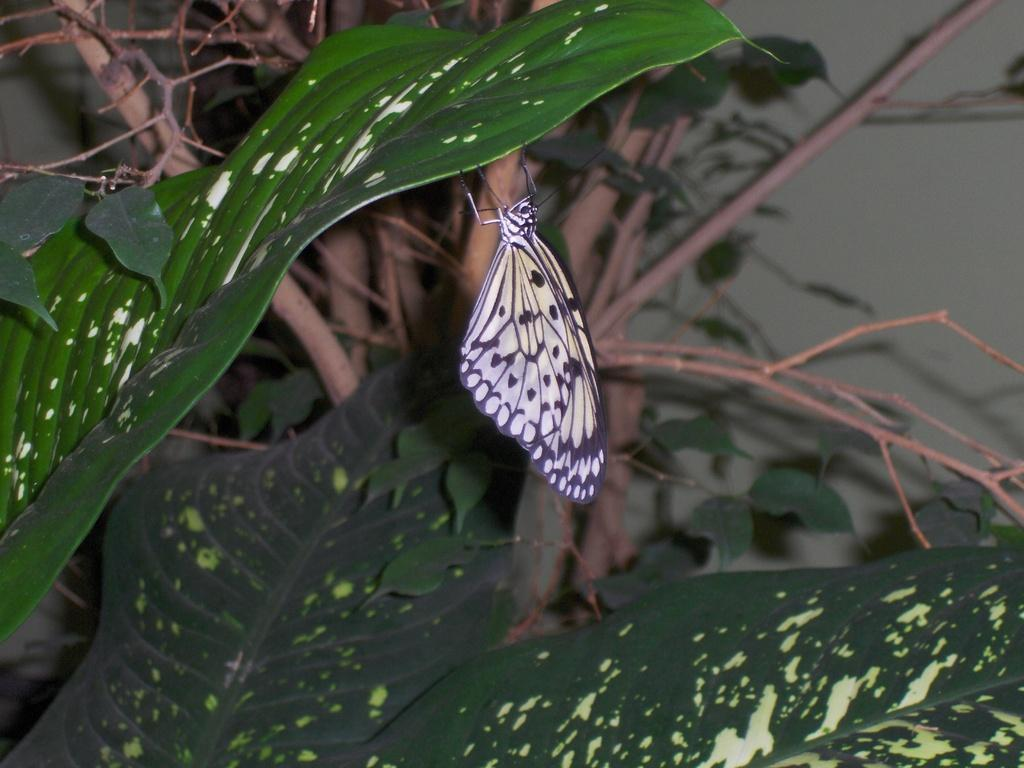What type of insect is present in the image? There is a butterfly in the image. What colors can be seen on the butterfly? The butterfly has yellow and black colors. What is the butterfly holding in the image? The butterfly is holding a leaf. What is the leaf attached to in the image? The leaf belongs to a tree. What type of record is being played by the butterfly in the image? There is no record present in the image; it features a butterfly holding a leaf. How many bears are visible in the image? There are no bears present in the image. 